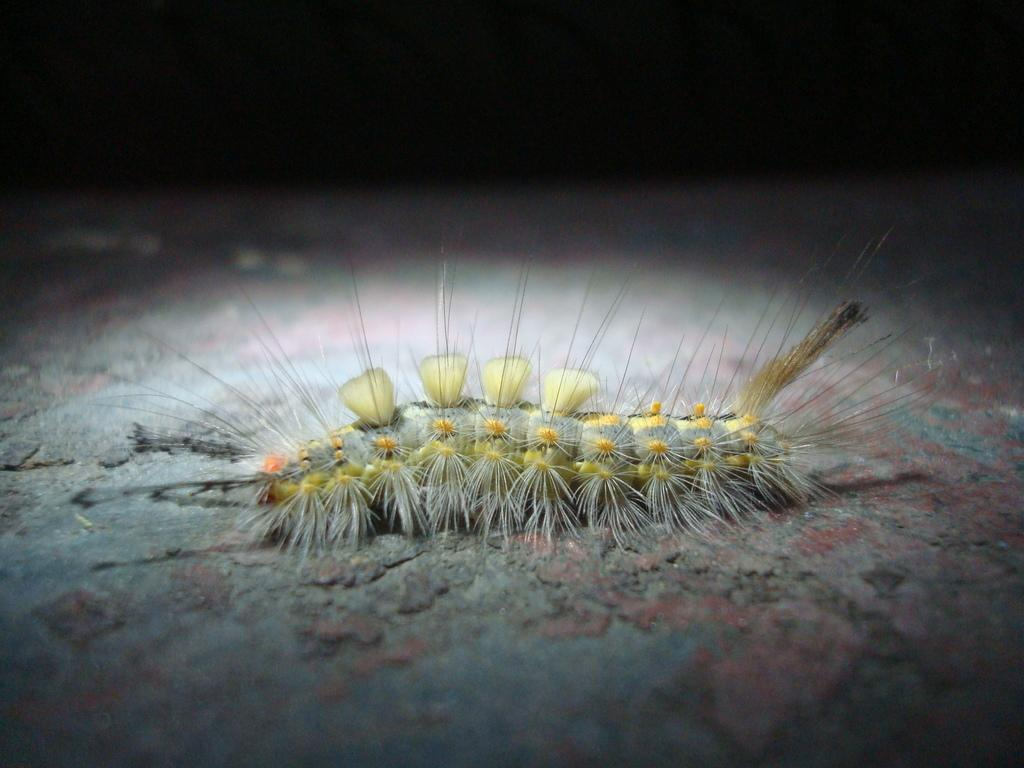What type of creature is present in the image? There is an insect in the image. What colors can be seen on the insect? The insect has yellow and grey colors. How would you describe the lighting in the image? The image appears to be darker in the background. What type of suit is the insect wearing in the image? There is no suit present in the image, as insects do not wear clothing. 